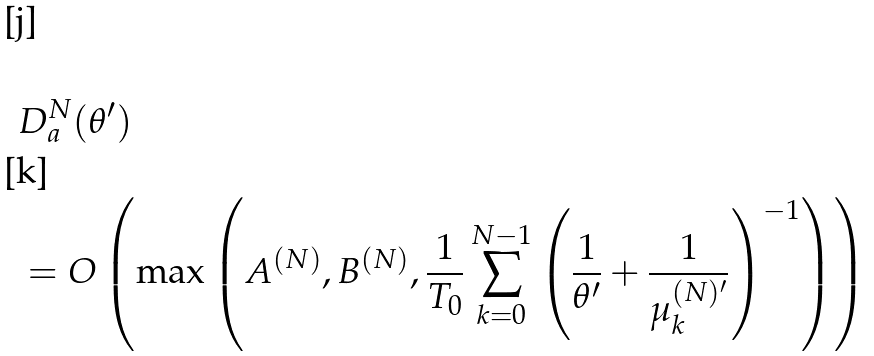Convert formula to latex. <formula><loc_0><loc_0><loc_500><loc_500>& D _ { a } ^ { N } ( \theta ^ { \prime } ) \\ & = O \left ( \max \left ( A ^ { ( N ) } , B ^ { ( N ) } , \frac { 1 } { T _ { 0 } } \sum _ { k = 0 } ^ { N - 1 } \left ( \frac { 1 } { \theta ^ { \prime } } + \frac { 1 } { \mu _ { k } ^ { ( N ) ^ { \prime } } } \right ) ^ { - 1 } \right ) \right )</formula> 